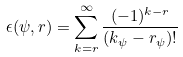<formula> <loc_0><loc_0><loc_500><loc_500>\epsilon ( \psi , r ) = \sum _ { k = r } ^ { \infty } \frac { ( - 1 ) ^ { k - r } } { ( k _ { \psi } - r _ { \psi } ) ! }</formula> 